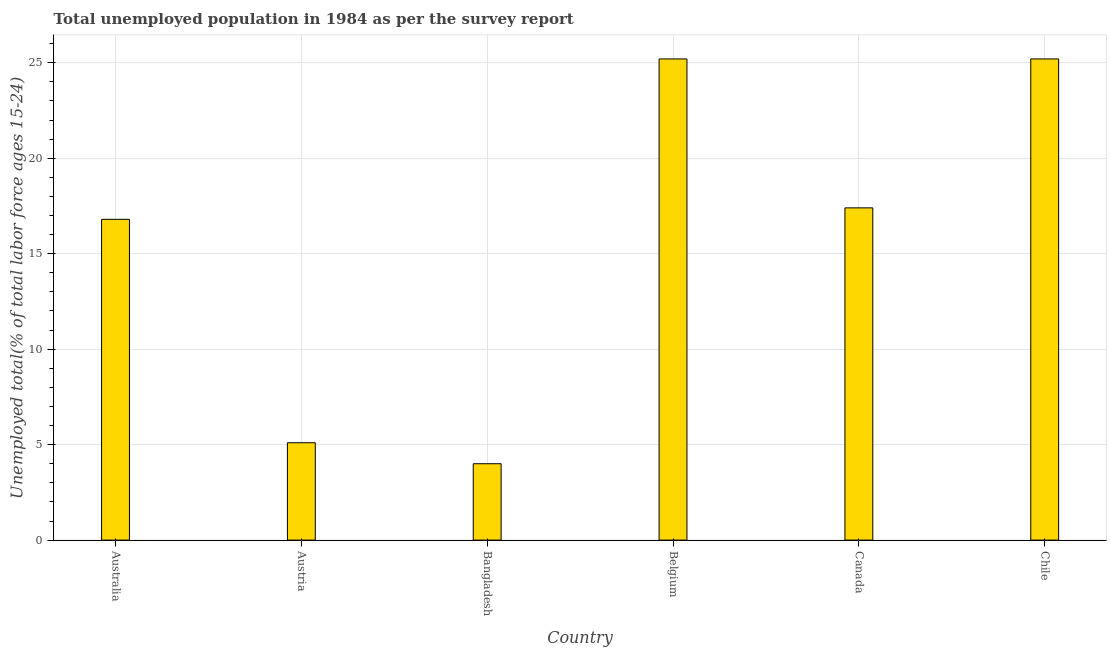Does the graph contain any zero values?
Offer a terse response. No. What is the title of the graph?
Give a very brief answer. Total unemployed population in 1984 as per the survey report. What is the label or title of the X-axis?
Offer a terse response. Country. What is the label or title of the Y-axis?
Keep it short and to the point. Unemployed total(% of total labor force ages 15-24). What is the unemployed youth in Austria?
Your answer should be compact. 5.1. Across all countries, what is the maximum unemployed youth?
Give a very brief answer. 25.2. In which country was the unemployed youth maximum?
Your response must be concise. Belgium. What is the sum of the unemployed youth?
Keep it short and to the point. 93.7. What is the average unemployed youth per country?
Offer a terse response. 15.62. What is the median unemployed youth?
Keep it short and to the point. 17.1. What is the ratio of the unemployed youth in Australia to that in Canada?
Provide a succinct answer. 0.97. Is the difference between the unemployed youth in Austria and Chile greater than the difference between any two countries?
Your answer should be very brief. No. What is the difference between the highest and the second highest unemployed youth?
Keep it short and to the point. 0. What is the difference between the highest and the lowest unemployed youth?
Your answer should be compact. 21.2. In how many countries, is the unemployed youth greater than the average unemployed youth taken over all countries?
Provide a succinct answer. 4. How many bars are there?
Provide a short and direct response. 6. Are all the bars in the graph horizontal?
Provide a short and direct response. No. What is the Unemployed total(% of total labor force ages 15-24) in Australia?
Offer a very short reply. 16.8. What is the Unemployed total(% of total labor force ages 15-24) of Austria?
Give a very brief answer. 5.1. What is the Unemployed total(% of total labor force ages 15-24) in Bangladesh?
Give a very brief answer. 4. What is the Unemployed total(% of total labor force ages 15-24) of Belgium?
Your answer should be compact. 25.2. What is the Unemployed total(% of total labor force ages 15-24) in Canada?
Make the answer very short. 17.4. What is the Unemployed total(% of total labor force ages 15-24) of Chile?
Make the answer very short. 25.2. What is the difference between the Unemployed total(% of total labor force ages 15-24) in Australia and Bangladesh?
Provide a succinct answer. 12.8. What is the difference between the Unemployed total(% of total labor force ages 15-24) in Australia and Canada?
Your answer should be compact. -0.6. What is the difference between the Unemployed total(% of total labor force ages 15-24) in Australia and Chile?
Your response must be concise. -8.4. What is the difference between the Unemployed total(% of total labor force ages 15-24) in Austria and Belgium?
Your answer should be very brief. -20.1. What is the difference between the Unemployed total(% of total labor force ages 15-24) in Austria and Canada?
Provide a short and direct response. -12.3. What is the difference between the Unemployed total(% of total labor force ages 15-24) in Austria and Chile?
Ensure brevity in your answer.  -20.1. What is the difference between the Unemployed total(% of total labor force ages 15-24) in Bangladesh and Belgium?
Ensure brevity in your answer.  -21.2. What is the difference between the Unemployed total(% of total labor force ages 15-24) in Bangladesh and Chile?
Ensure brevity in your answer.  -21.2. What is the ratio of the Unemployed total(% of total labor force ages 15-24) in Australia to that in Austria?
Provide a succinct answer. 3.29. What is the ratio of the Unemployed total(% of total labor force ages 15-24) in Australia to that in Belgium?
Offer a terse response. 0.67. What is the ratio of the Unemployed total(% of total labor force ages 15-24) in Australia to that in Chile?
Give a very brief answer. 0.67. What is the ratio of the Unemployed total(% of total labor force ages 15-24) in Austria to that in Bangladesh?
Give a very brief answer. 1.27. What is the ratio of the Unemployed total(% of total labor force ages 15-24) in Austria to that in Belgium?
Make the answer very short. 0.2. What is the ratio of the Unemployed total(% of total labor force ages 15-24) in Austria to that in Canada?
Make the answer very short. 0.29. What is the ratio of the Unemployed total(% of total labor force ages 15-24) in Austria to that in Chile?
Offer a very short reply. 0.2. What is the ratio of the Unemployed total(% of total labor force ages 15-24) in Bangladesh to that in Belgium?
Your answer should be compact. 0.16. What is the ratio of the Unemployed total(% of total labor force ages 15-24) in Bangladesh to that in Canada?
Your answer should be compact. 0.23. What is the ratio of the Unemployed total(% of total labor force ages 15-24) in Bangladesh to that in Chile?
Ensure brevity in your answer.  0.16. What is the ratio of the Unemployed total(% of total labor force ages 15-24) in Belgium to that in Canada?
Provide a succinct answer. 1.45. What is the ratio of the Unemployed total(% of total labor force ages 15-24) in Canada to that in Chile?
Give a very brief answer. 0.69. 